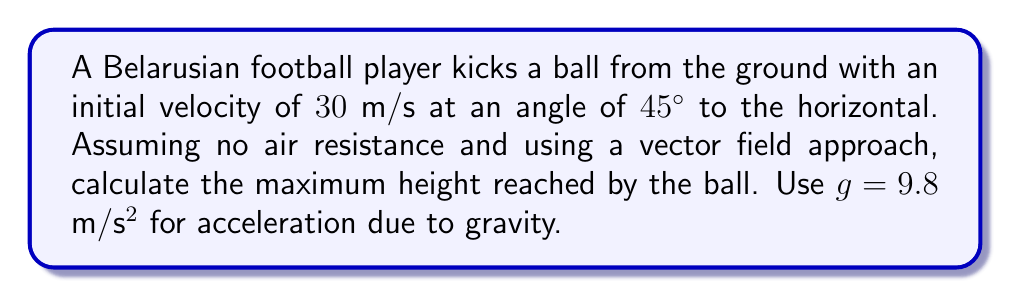Show me your answer to this math problem. Let's approach this step-by-step using vector fields:

1) First, we define our vector field. The ball's motion is influenced by gravity, which can be represented as a constant vector field:

   $$\mathbf{F}(x,y) = \langle 0, -g \rangle = \langle 0, -9.8 \rangle \text{ m/s²}$$

2) The initial velocity vector can be broken down into components:
   
   $$v_x = 30 \cos(45°) = 30 \cdot \frac{\sqrt{2}}{2} \approx 21.21 \text{ m/s}$$
   $$v_y = 30 \sin(45°) = 30 \cdot \frac{\sqrt{2}}{2} \approx 21.21 \text{ m/s}$$

3) The velocity vector at any time $t$ is given by:

   $$\mathbf{v}(t) = \langle v_x, v_y - gt \rangle$$

4) The maximum height is reached when the vertical component of velocity becomes zero. We can find this time:

   $$21.21 - 9.8t = 0$$
   $$t = \frac{21.21}{9.8} \approx 2.16 \text{ s}$$

5) Now, we can find the maximum height using the equation:

   $$y(t) = v_y t - \frac{1}{2}gt^2$$

6) Substituting our values:

   $$y(2.16) = 21.21 \cdot 2.16 - \frac{1}{2} \cdot 9.8 \cdot 2.16^2$$
   $$\approx 45.81 - 22.90 = 22.91 \text{ m}$$

Therefore, the maximum height reached by the ball is approximately 22.91 meters.
Answer: 22.91 m 